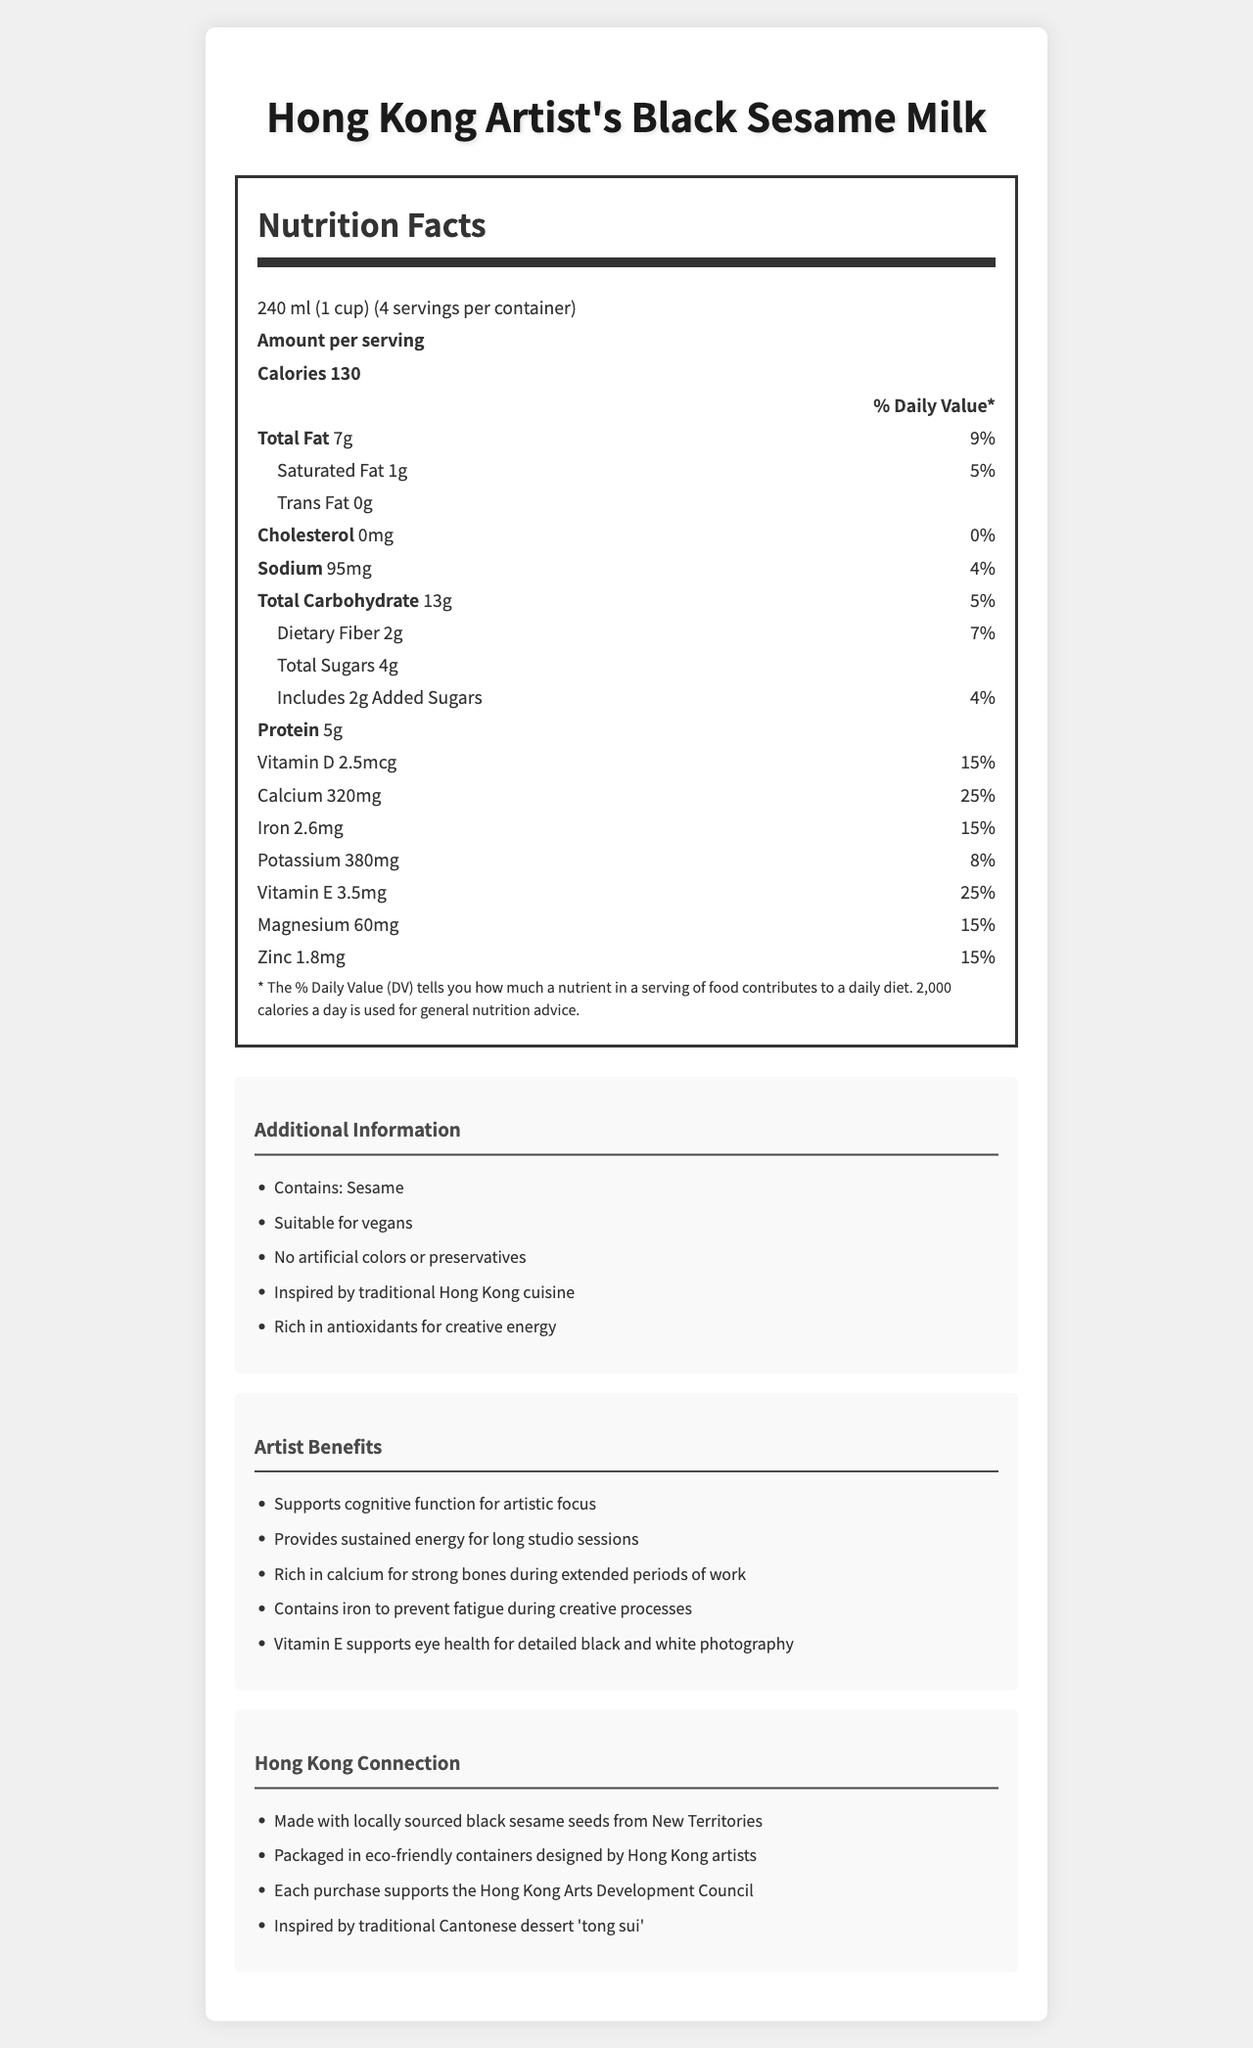What is the serving size of Hong Kong Artist's Black Sesame Milk? The serving size is mentioned at the beginning of the nutrition facts section under the title "Nutrition Facts".
Answer: 240 ml (1 cup) How many servings are there in one container of Hong Kong Artist's Black Sesame Milk? The "servings per container" is listed as 4 right after the serving size in the nutrition facts section.
Answer: 4 How many calories are in one serving of Hong Kong Artist's Black Sesame Milk? The calories per serving are stated as 130 right below the "Amount per serving" title.
Answer: 130 What percentage of the daily value of total fat does one serving of Hong Kong Artist's Black Sesame Milk contain? The total fat amount and its daily value percentage (9%) are listed right after the calories information.
Answer: 9% How much saturated fat is in a serving? The amount of saturated fat is listed as 1 g in the nutrition facts section under total fat.
Answer: 1 g How much cholesterol does Hong Kong Artist's Black Sesame Milk have per serving? Cholesterol amount per serving is clearly stated as 0 mg.
Answer: 0 mg Which vitamin in Hong Kong Artist's Black Sesame Milk supports eye health for detailed black and white photography? A. Vitamin D B. Vitamin C C. Vitamin E The document mentions "Vitamin E supports eye health for detailed black and white photography" in the "Artist Benefits" section.
Answer: C. Vitamin E What mineral is in the highest amount in Hong Kong Artist's Black Sesame Milk per serving? A. Calcium B. Iron C. Potassium Calcium is listed at 320 mg per serving, which is higher than both iron and potassium in the nutritional facts.
Answer: A. Calcium How much protein does Hong Kong Artist's Black Sesame Milk contain per serving? The amount of protein is listed as 5 g in the nutrition facts section.
Answer: 5 g Is Hong Kong Artist's Black Sesame Milk suitable for vegans? It is mentioned in the additional information section as "Suitable for vegans".
Answer: Yes Describe the main artistic benefit of Hong Kong Artist's Black Sesame Milk. This benefit is prominently stated in the "Artist Benefits" section.
Answer: Supports cognitive function for artistic focus How much iron does one serving of Hong Kong Artist's Black Sesame Milk contain? Iron is listed as 2.6 mg per serving in the nutrition facts section.
Answer: 2.6 mg How does Hong Kong Artist's Black Sesame Milk support Hong Kong arts? It is mentioned in the "Hong Kong Connection" section that each purchase supports the Hong Kong Arts Development Council.
Answer: Each purchase supports the Hong Kong Arts Development Council How many grams of dietary fiber are in one serving? The amount of dietary fiber is listed as 2 g under total carbohydrates in the nutrition facts section.
Answer: 2 g Is the Hong Kong Artist's Black Sesame Milk made with locally sourced ingredients? The document states, "Made with locally sourced black sesame seeds from New Territories" in the "Hong Kong Connection" section.
Answer: Yes Summarize the document The document includes detailed nutritional information, artist benefits, additional product benefits, and cultural connections to Hong Kong, packaged in an artistically designed label.
Answer: The document provides a detailed look at the nutrition facts label of Hong Kong Artist's Black Sesame Milk, including information about serving size, calorie content, and various nutrients. It highlights the additional benefits for artists, connections to Hong Kong culture, and ensures the product is suitable for vegans. It also emphasizes its support for local art communities and eco-friendly packaging. What company manufactures Hong Kong Artist's Black Sesame Milk? The document does not provide information about the manufacturer of the product.
Answer: Cannot be determined 